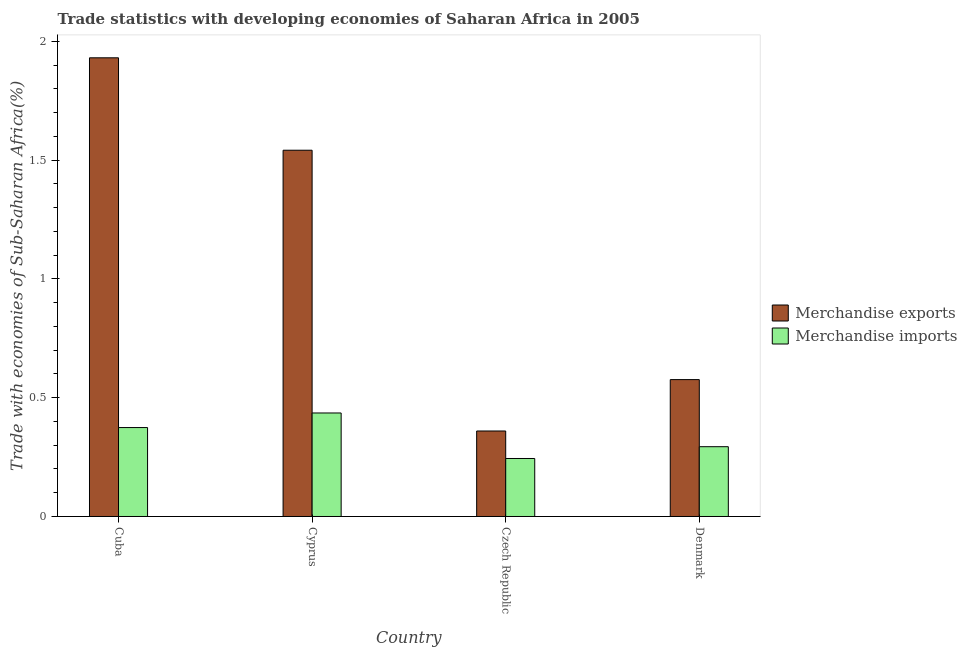Are the number of bars per tick equal to the number of legend labels?
Your answer should be very brief. Yes. Are the number of bars on each tick of the X-axis equal?
Ensure brevity in your answer.  Yes. What is the label of the 3rd group of bars from the left?
Give a very brief answer. Czech Republic. What is the merchandise exports in Czech Republic?
Keep it short and to the point. 0.36. Across all countries, what is the maximum merchandise imports?
Offer a very short reply. 0.44. Across all countries, what is the minimum merchandise imports?
Offer a terse response. 0.24. In which country was the merchandise imports maximum?
Keep it short and to the point. Cyprus. In which country was the merchandise exports minimum?
Your answer should be very brief. Czech Republic. What is the total merchandise imports in the graph?
Make the answer very short. 1.35. What is the difference between the merchandise exports in Cyprus and that in Czech Republic?
Provide a succinct answer. 1.18. What is the difference between the merchandise imports in Cuba and the merchandise exports in Cyprus?
Provide a succinct answer. -1.17. What is the average merchandise imports per country?
Provide a short and direct response. 0.34. What is the difference between the merchandise imports and merchandise exports in Denmark?
Give a very brief answer. -0.28. What is the ratio of the merchandise exports in Cuba to that in Denmark?
Give a very brief answer. 3.35. Is the difference between the merchandise imports in Cyprus and Czech Republic greater than the difference between the merchandise exports in Cyprus and Czech Republic?
Make the answer very short. No. What is the difference between the highest and the second highest merchandise exports?
Your response must be concise. 0.39. What is the difference between the highest and the lowest merchandise imports?
Offer a terse response. 0.19. In how many countries, is the merchandise exports greater than the average merchandise exports taken over all countries?
Give a very brief answer. 2. Is the sum of the merchandise imports in Cyprus and Czech Republic greater than the maximum merchandise exports across all countries?
Your answer should be compact. No. What does the 1st bar from the right in Cuba represents?
Offer a very short reply. Merchandise imports. How many bars are there?
Provide a succinct answer. 8. Are all the bars in the graph horizontal?
Your response must be concise. No. Are the values on the major ticks of Y-axis written in scientific E-notation?
Give a very brief answer. No. Does the graph contain grids?
Provide a short and direct response. No. How many legend labels are there?
Give a very brief answer. 2. What is the title of the graph?
Provide a succinct answer. Trade statistics with developing economies of Saharan Africa in 2005. What is the label or title of the Y-axis?
Offer a very short reply. Trade with economies of Sub-Saharan Africa(%). What is the Trade with economies of Sub-Saharan Africa(%) of Merchandise exports in Cuba?
Ensure brevity in your answer.  1.93. What is the Trade with economies of Sub-Saharan Africa(%) of Merchandise imports in Cuba?
Give a very brief answer. 0.37. What is the Trade with economies of Sub-Saharan Africa(%) of Merchandise exports in Cyprus?
Provide a succinct answer. 1.54. What is the Trade with economies of Sub-Saharan Africa(%) of Merchandise imports in Cyprus?
Provide a succinct answer. 0.44. What is the Trade with economies of Sub-Saharan Africa(%) in Merchandise exports in Czech Republic?
Your answer should be compact. 0.36. What is the Trade with economies of Sub-Saharan Africa(%) of Merchandise imports in Czech Republic?
Make the answer very short. 0.24. What is the Trade with economies of Sub-Saharan Africa(%) of Merchandise exports in Denmark?
Offer a very short reply. 0.58. What is the Trade with economies of Sub-Saharan Africa(%) of Merchandise imports in Denmark?
Offer a very short reply. 0.29. Across all countries, what is the maximum Trade with economies of Sub-Saharan Africa(%) of Merchandise exports?
Provide a short and direct response. 1.93. Across all countries, what is the maximum Trade with economies of Sub-Saharan Africa(%) in Merchandise imports?
Your response must be concise. 0.44. Across all countries, what is the minimum Trade with economies of Sub-Saharan Africa(%) of Merchandise exports?
Keep it short and to the point. 0.36. Across all countries, what is the minimum Trade with economies of Sub-Saharan Africa(%) of Merchandise imports?
Give a very brief answer. 0.24. What is the total Trade with economies of Sub-Saharan Africa(%) of Merchandise exports in the graph?
Ensure brevity in your answer.  4.41. What is the total Trade with economies of Sub-Saharan Africa(%) in Merchandise imports in the graph?
Ensure brevity in your answer.  1.35. What is the difference between the Trade with economies of Sub-Saharan Africa(%) in Merchandise exports in Cuba and that in Cyprus?
Your answer should be very brief. 0.39. What is the difference between the Trade with economies of Sub-Saharan Africa(%) of Merchandise imports in Cuba and that in Cyprus?
Give a very brief answer. -0.06. What is the difference between the Trade with economies of Sub-Saharan Africa(%) in Merchandise exports in Cuba and that in Czech Republic?
Ensure brevity in your answer.  1.57. What is the difference between the Trade with economies of Sub-Saharan Africa(%) of Merchandise imports in Cuba and that in Czech Republic?
Keep it short and to the point. 0.13. What is the difference between the Trade with economies of Sub-Saharan Africa(%) in Merchandise exports in Cuba and that in Denmark?
Keep it short and to the point. 1.35. What is the difference between the Trade with economies of Sub-Saharan Africa(%) of Merchandise imports in Cuba and that in Denmark?
Make the answer very short. 0.08. What is the difference between the Trade with economies of Sub-Saharan Africa(%) in Merchandise exports in Cyprus and that in Czech Republic?
Offer a very short reply. 1.18. What is the difference between the Trade with economies of Sub-Saharan Africa(%) of Merchandise imports in Cyprus and that in Czech Republic?
Your response must be concise. 0.19. What is the difference between the Trade with economies of Sub-Saharan Africa(%) in Merchandise exports in Cyprus and that in Denmark?
Make the answer very short. 0.97. What is the difference between the Trade with economies of Sub-Saharan Africa(%) in Merchandise imports in Cyprus and that in Denmark?
Provide a short and direct response. 0.14. What is the difference between the Trade with economies of Sub-Saharan Africa(%) of Merchandise exports in Czech Republic and that in Denmark?
Make the answer very short. -0.22. What is the difference between the Trade with economies of Sub-Saharan Africa(%) in Merchandise imports in Czech Republic and that in Denmark?
Your answer should be compact. -0.05. What is the difference between the Trade with economies of Sub-Saharan Africa(%) in Merchandise exports in Cuba and the Trade with economies of Sub-Saharan Africa(%) in Merchandise imports in Cyprus?
Provide a succinct answer. 1.5. What is the difference between the Trade with economies of Sub-Saharan Africa(%) in Merchandise exports in Cuba and the Trade with economies of Sub-Saharan Africa(%) in Merchandise imports in Czech Republic?
Provide a succinct answer. 1.69. What is the difference between the Trade with economies of Sub-Saharan Africa(%) of Merchandise exports in Cuba and the Trade with economies of Sub-Saharan Africa(%) of Merchandise imports in Denmark?
Offer a very short reply. 1.64. What is the difference between the Trade with economies of Sub-Saharan Africa(%) of Merchandise exports in Cyprus and the Trade with economies of Sub-Saharan Africa(%) of Merchandise imports in Czech Republic?
Ensure brevity in your answer.  1.3. What is the difference between the Trade with economies of Sub-Saharan Africa(%) of Merchandise exports in Cyprus and the Trade with economies of Sub-Saharan Africa(%) of Merchandise imports in Denmark?
Offer a terse response. 1.25. What is the difference between the Trade with economies of Sub-Saharan Africa(%) of Merchandise exports in Czech Republic and the Trade with economies of Sub-Saharan Africa(%) of Merchandise imports in Denmark?
Offer a very short reply. 0.07. What is the average Trade with economies of Sub-Saharan Africa(%) of Merchandise exports per country?
Provide a short and direct response. 1.1. What is the average Trade with economies of Sub-Saharan Africa(%) of Merchandise imports per country?
Offer a very short reply. 0.34. What is the difference between the Trade with economies of Sub-Saharan Africa(%) in Merchandise exports and Trade with economies of Sub-Saharan Africa(%) in Merchandise imports in Cuba?
Your answer should be very brief. 1.56. What is the difference between the Trade with economies of Sub-Saharan Africa(%) in Merchandise exports and Trade with economies of Sub-Saharan Africa(%) in Merchandise imports in Cyprus?
Ensure brevity in your answer.  1.11. What is the difference between the Trade with economies of Sub-Saharan Africa(%) of Merchandise exports and Trade with economies of Sub-Saharan Africa(%) of Merchandise imports in Czech Republic?
Provide a succinct answer. 0.12. What is the difference between the Trade with economies of Sub-Saharan Africa(%) in Merchandise exports and Trade with economies of Sub-Saharan Africa(%) in Merchandise imports in Denmark?
Provide a succinct answer. 0.28. What is the ratio of the Trade with economies of Sub-Saharan Africa(%) of Merchandise exports in Cuba to that in Cyprus?
Provide a succinct answer. 1.25. What is the ratio of the Trade with economies of Sub-Saharan Africa(%) in Merchandise imports in Cuba to that in Cyprus?
Offer a terse response. 0.86. What is the ratio of the Trade with economies of Sub-Saharan Africa(%) of Merchandise exports in Cuba to that in Czech Republic?
Provide a short and direct response. 5.37. What is the ratio of the Trade with economies of Sub-Saharan Africa(%) of Merchandise imports in Cuba to that in Czech Republic?
Your answer should be compact. 1.53. What is the ratio of the Trade with economies of Sub-Saharan Africa(%) of Merchandise exports in Cuba to that in Denmark?
Provide a short and direct response. 3.35. What is the ratio of the Trade with economies of Sub-Saharan Africa(%) in Merchandise imports in Cuba to that in Denmark?
Ensure brevity in your answer.  1.27. What is the ratio of the Trade with economies of Sub-Saharan Africa(%) of Merchandise exports in Cyprus to that in Czech Republic?
Provide a succinct answer. 4.28. What is the ratio of the Trade with economies of Sub-Saharan Africa(%) of Merchandise imports in Cyprus to that in Czech Republic?
Offer a terse response. 1.78. What is the ratio of the Trade with economies of Sub-Saharan Africa(%) of Merchandise exports in Cyprus to that in Denmark?
Your answer should be very brief. 2.68. What is the ratio of the Trade with economies of Sub-Saharan Africa(%) in Merchandise imports in Cyprus to that in Denmark?
Your response must be concise. 1.48. What is the ratio of the Trade with economies of Sub-Saharan Africa(%) in Merchandise exports in Czech Republic to that in Denmark?
Offer a terse response. 0.62. What is the ratio of the Trade with economies of Sub-Saharan Africa(%) in Merchandise imports in Czech Republic to that in Denmark?
Offer a terse response. 0.83. What is the difference between the highest and the second highest Trade with economies of Sub-Saharan Africa(%) in Merchandise exports?
Your response must be concise. 0.39. What is the difference between the highest and the second highest Trade with economies of Sub-Saharan Africa(%) in Merchandise imports?
Ensure brevity in your answer.  0.06. What is the difference between the highest and the lowest Trade with economies of Sub-Saharan Africa(%) in Merchandise exports?
Make the answer very short. 1.57. What is the difference between the highest and the lowest Trade with economies of Sub-Saharan Africa(%) in Merchandise imports?
Give a very brief answer. 0.19. 